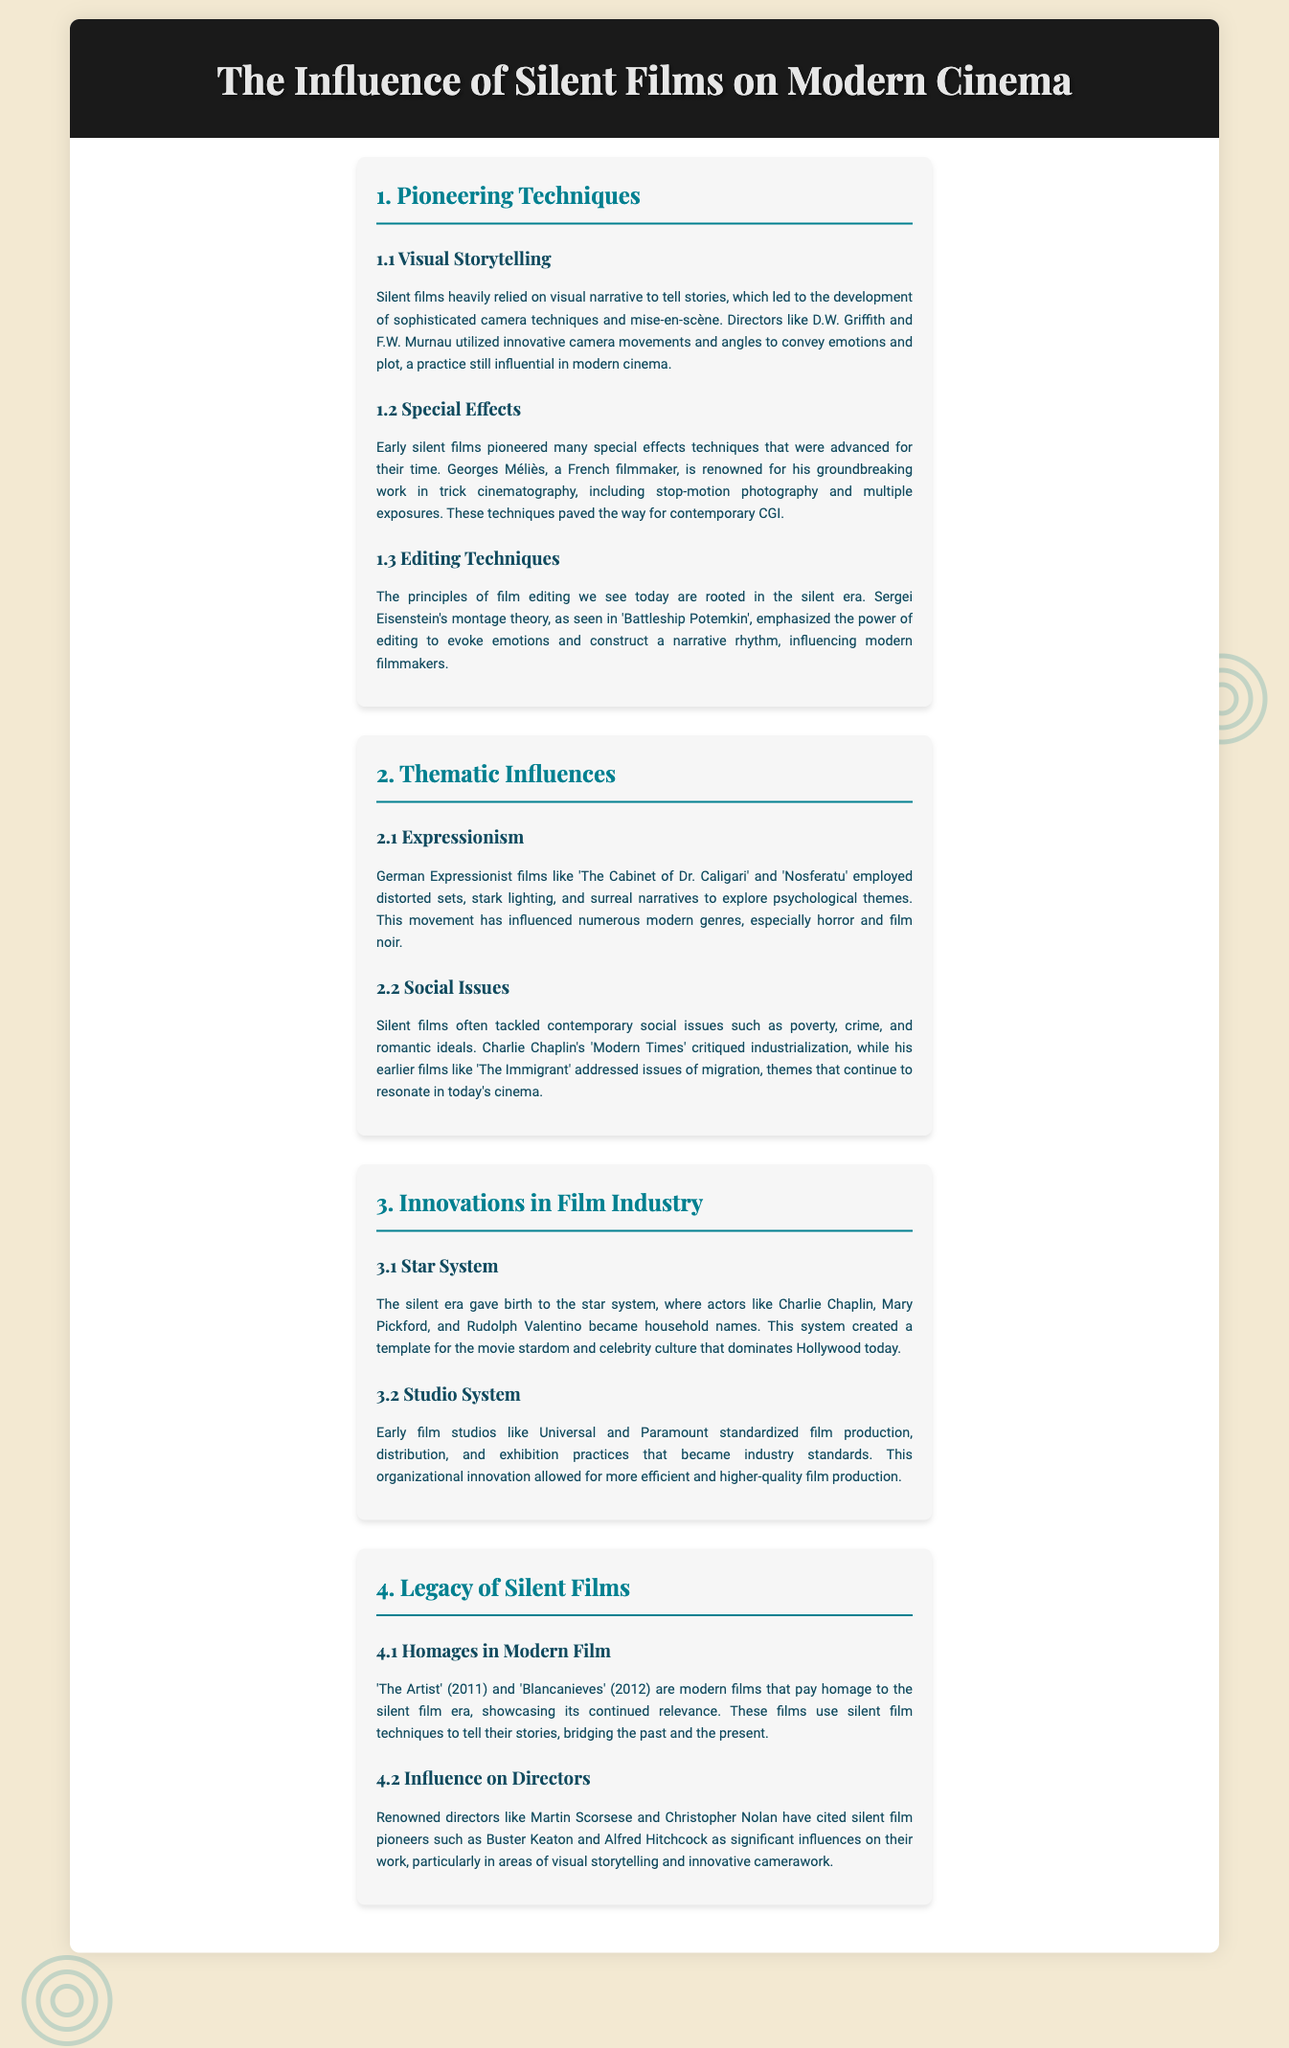What are the pioneering techniques mentioned? The section outlines the key techniques developed during the silent film era, including visual storytelling, special effects, and editing techniques.
Answer: Visual storytelling, special effects, editing techniques Who is known for trick cinematography? Georges Méliès is highlighted as a key figure in pioneering special effects techniques in silent films.
Answer: Georges Méliès What theme is associated with German Expressionist films? This thematic influence discusses the use of distorted sets and psychological exploration in films.
Answer: Expressionism Which silent film discussed social issues related to industrialization? Charlie Chaplin's film critiques industrial themes during the silent era.
Answer: Modern Times What year was the film "The Artist" released? The document mentions the release year of the film that honors silent cinema.
Answer: 2011 What did the star system introduce? The section explains the development of the star system, which shaped movie stardom and celebrity culture.
Answer: Star system Who are two modern directors influenced by silent film pioneers? This section cites influential directors who have acknowledged the impact of silent filmmakers in their own work.
Answer: Martin Scorsese, Christopher Nolan 